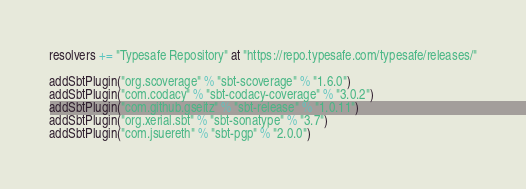<code> <loc_0><loc_0><loc_500><loc_500><_Scala_>resolvers += "Typesafe Repository" at "https://repo.typesafe.com/typesafe/releases/"

addSbtPlugin("org.scoverage" % "sbt-scoverage" % "1.6.0")
addSbtPlugin("com.codacy" % "sbt-codacy-coverage" % "3.0.2")
addSbtPlugin("com.github.gseitz" % "sbt-release" % "1.0.11")
addSbtPlugin("org.xerial.sbt" % "sbt-sonatype" % "3.7")
addSbtPlugin("com.jsuereth" % "sbt-pgp" % "2.0.0")
</code> 